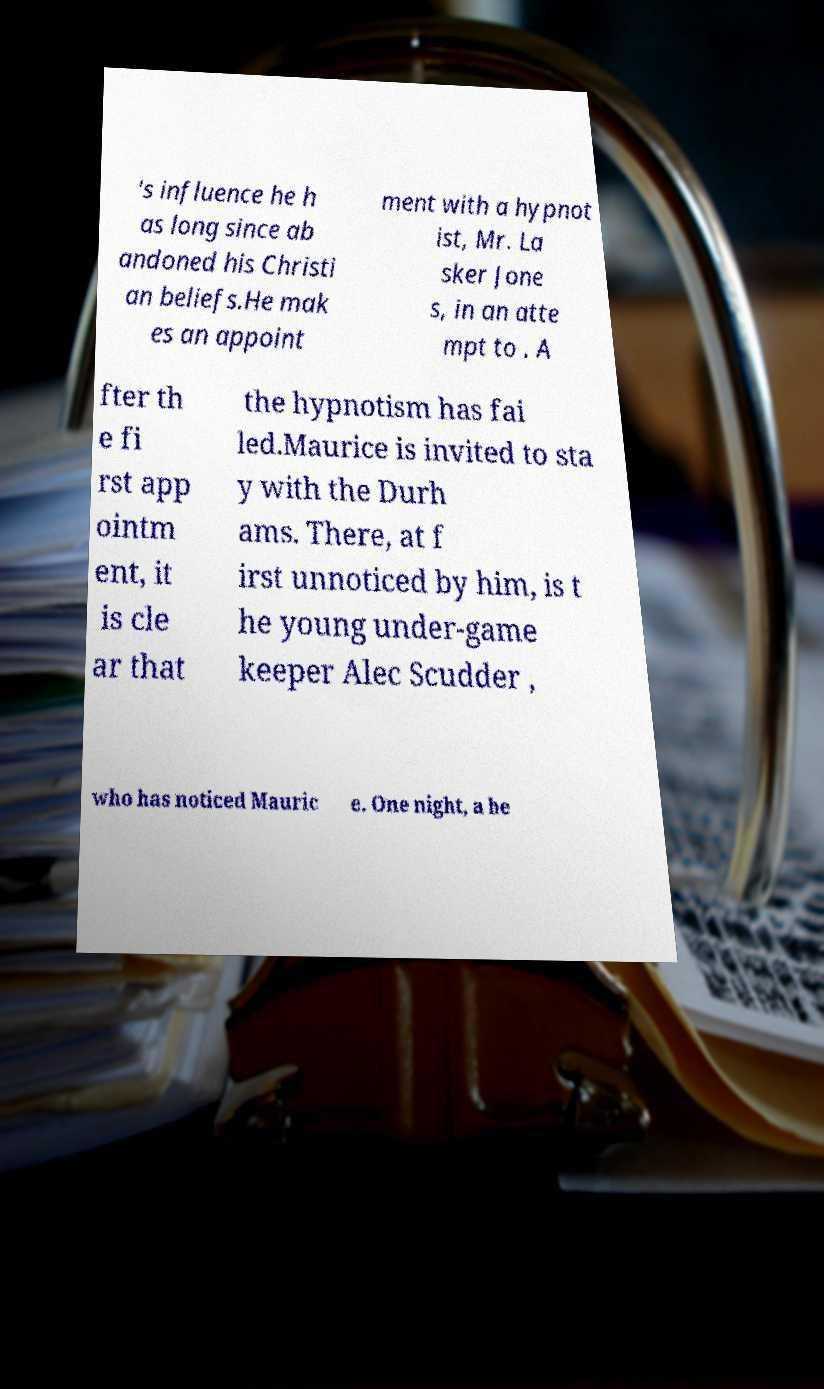What messages or text are displayed in this image? I need them in a readable, typed format. 's influence he h as long since ab andoned his Christi an beliefs.He mak es an appoint ment with a hypnot ist, Mr. La sker Jone s, in an atte mpt to . A fter th e fi rst app ointm ent, it is cle ar that the hypnotism has fai led.Maurice is invited to sta y with the Durh ams. There, at f irst unnoticed by him, is t he young under-game keeper Alec Scudder , who has noticed Mauric e. One night, a he 